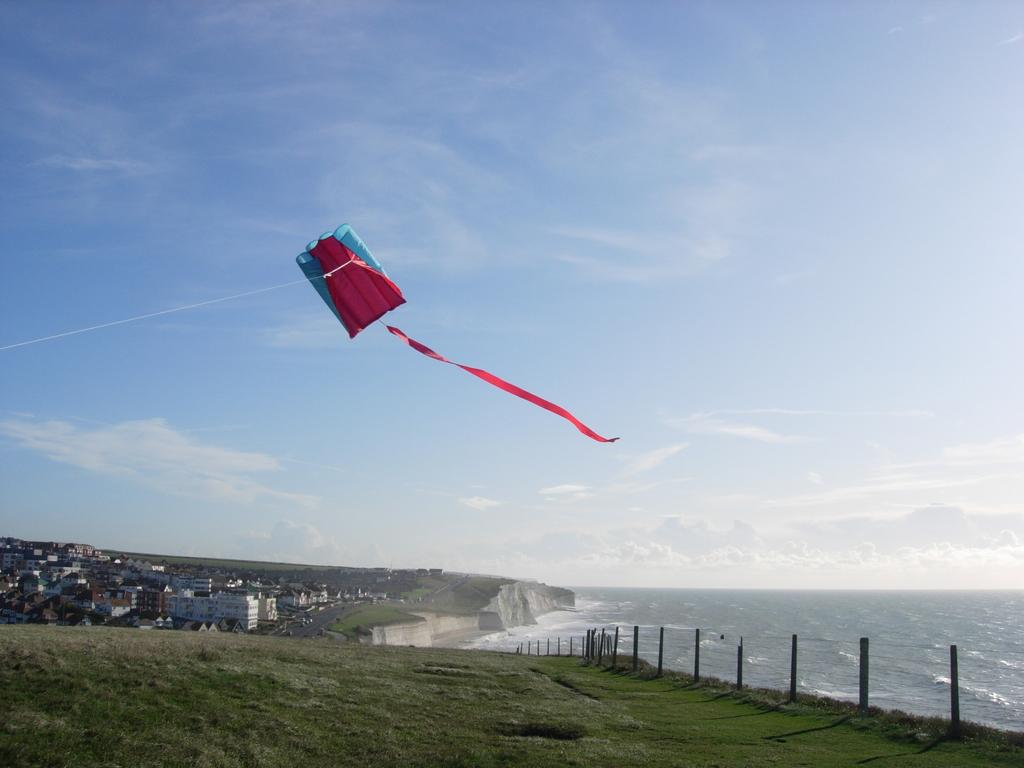What is the main subject of the image? There is a kite flying in the image. What else can be seen in the image besides the kite? Buildings, water, a fence, and grass are visible in the image. What is the condition of the sky in the image? The sky with clouds is visible in the background of the image. What type of calculator can be seen in the image? There is no calculator present in the image. What is the kite writing on the buildings in the image? The kite is not writing on the buildings; it is simply flying in the image. 